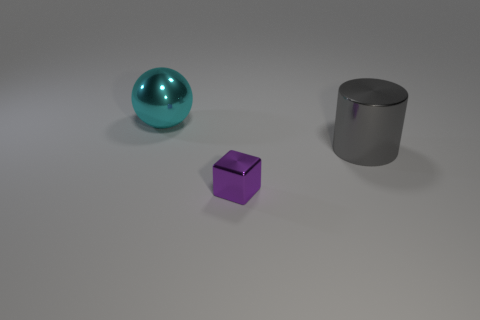Do the gray metal object and the large cyan thing have the same shape?
Offer a very short reply. No. How many large metallic things are right of the big cyan metallic sphere and left of the purple shiny object?
Your response must be concise. 0. How many rubber objects are green cylinders or gray cylinders?
Offer a very short reply. 0. There is a metallic object that is in front of the big thing on the right side of the cyan object; how big is it?
Give a very brief answer. Small. There is a large object on the left side of the large thing in front of the metal ball; are there any cylinders that are right of it?
Offer a terse response. Yes. What number of objects are yellow metal cylinders or things left of the gray metal cylinder?
Ensure brevity in your answer.  2. What number of tiny things have the same shape as the large gray thing?
Your answer should be very brief. 0. There is a metallic object to the left of the metal thing in front of the object that is right of the small purple block; what is its size?
Make the answer very short. Large. What number of gray objects are either shiny cylinders or cubes?
Offer a very short reply. 1. How many things are the same size as the block?
Provide a succinct answer. 0. 